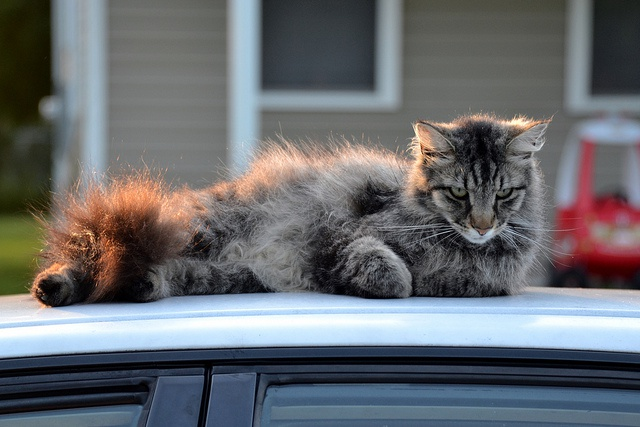Describe the objects in this image and their specific colors. I can see car in black, lightblue, and navy tones and cat in black, gray, darkgray, and tan tones in this image. 